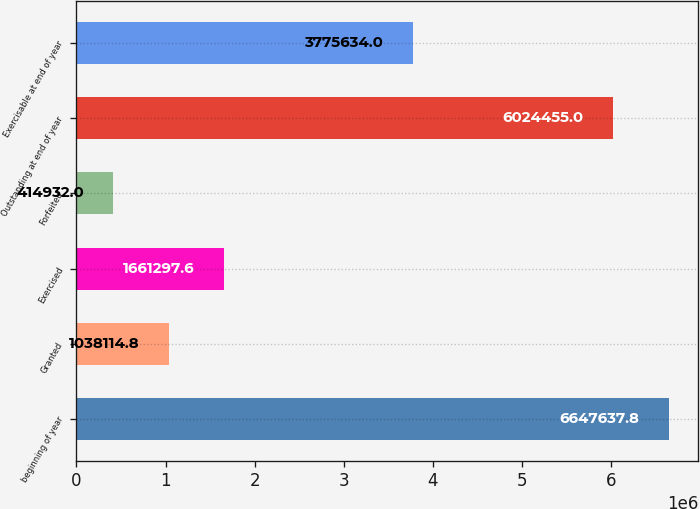<chart> <loc_0><loc_0><loc_500><loc_500><bar_chart><fcel>beginning of year<fcel>Granted<fcel>Exercised<fcel>Forfeited<fcel>Outstanding at end of year<fcel>Exercisable at end of year<nl><fcel>6.64764e+06<fcel>1.03811e+06<fcel>1.6613e+06<fcel>414932<fcel>6.02446e+06<fcel>3.77563e+06<nl></chart> 